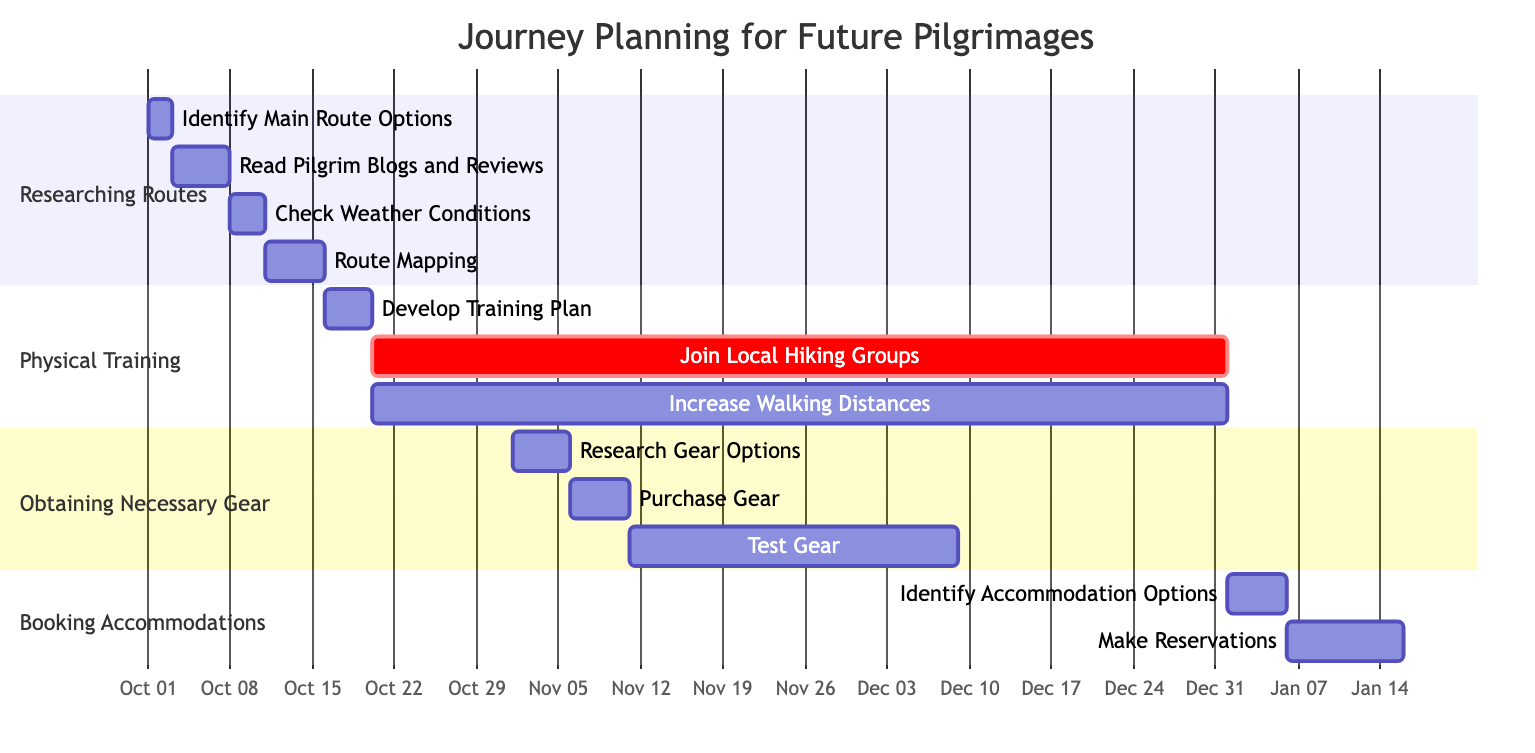What is the duration of the "Route Mapping" task? The "Route Mapping" task starts on October 11, 2023, and lasts for 5 days, so its duration is 5 days.
Answer: 5 days What starts on October 16, 2023? The "Physical Training" section begins on October 16, 2023, indicating the starting point for training-related activities.
Answer: Physical Training How many details are there in the "Obtaining Necessary Gear" section? The "Obtaining Necessary Gear" section has 3 details: "Research Gear Options", "Purchase Gear", and "Test Gear", indicating the specific tasks to be completed.
Answer: 3 Which task overlaps with "Join Local Hiking Groups"? "Increase Walking Distances" overlaps with "Join Local Hiking Groups" since both tasks start on October 20, 2023, and continue for 73 days.
Answer: Increase Walking Distances When is the last task in the "Booking Accommodations" section scheduled to end? The "Make Reservations" task ends on January 15, 2024, which is the last task in the "Booking Accommodations" section, showing the timeline for securing a place to stay.
Answer: January 15, 2024 How long will "Test Gear" be conducted? "Test Gear" lasts for 4 weeks, or 28 days, as indicated in the "Obtaining Necessary Gear" section, highlighting the importance of ensuring comfort before the pilgrimage.
Answer: 28 days What is the total duration of the "Researching Routes" section? "Researching Routes" covers a period from October 1 to October 15, 2023, lasting 15 days total, necessary for planning the journey effectively.
Answer: 15 days How many sections are there in the Gantt chart? There are 4 sections: "Researching Routes", "Physical Training", "Obtaining Necessary Gear", and "Booking Accommodations", which outline the essential steps for pilgrimage preparation.
Answer: 4 